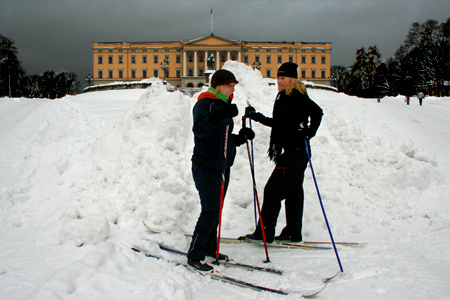Can you give a detailed description of the scene? The image depicts two individuals engaging in cross-country skiing in front of a monumental building. The ground is covered with snow, and the sky appears dark and overcast, suggesting a cold winter day. The building in the background has a classic architectural style, with columns and a central triangular pediment. Both individuals are dressed warmly—one is wearing a black jacket and a black cap while the other has a colorful scarf and dark pants. They seem to be conversing or preparing for their ski journey. What do you think their conversation is about? They might be discussing their skiing plans for the day or commenting on the weather conditions. Alternatively, they could be talking about the beautiful scenery they are experiencing or arranging to meet up with friends later. 